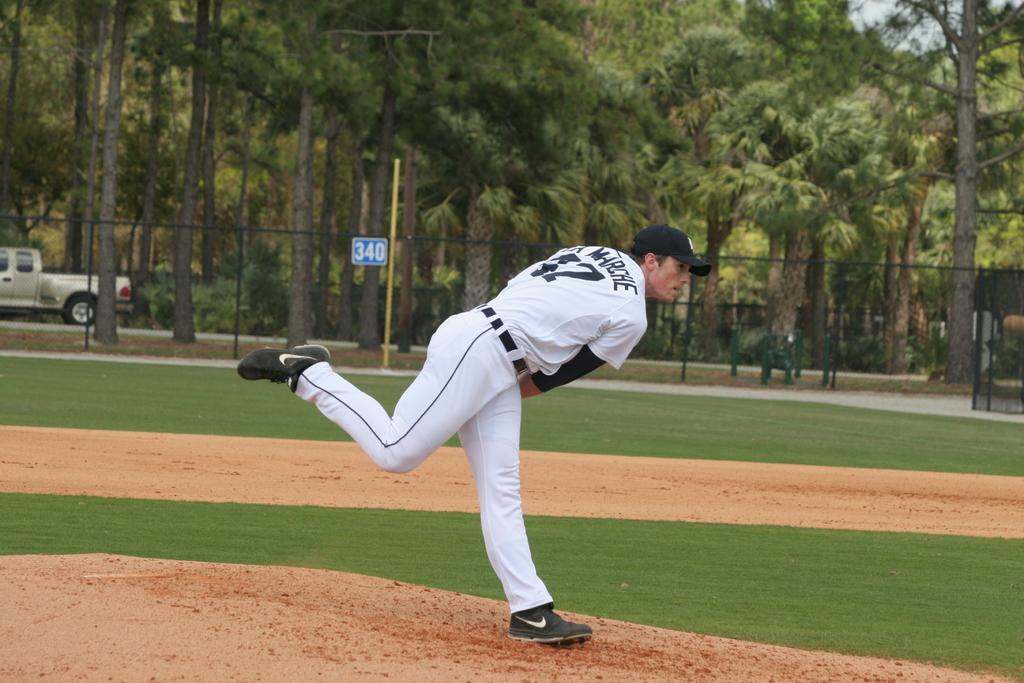<image>
Describe the image concisely. Blue and white sign with number 340 on a black fence. 